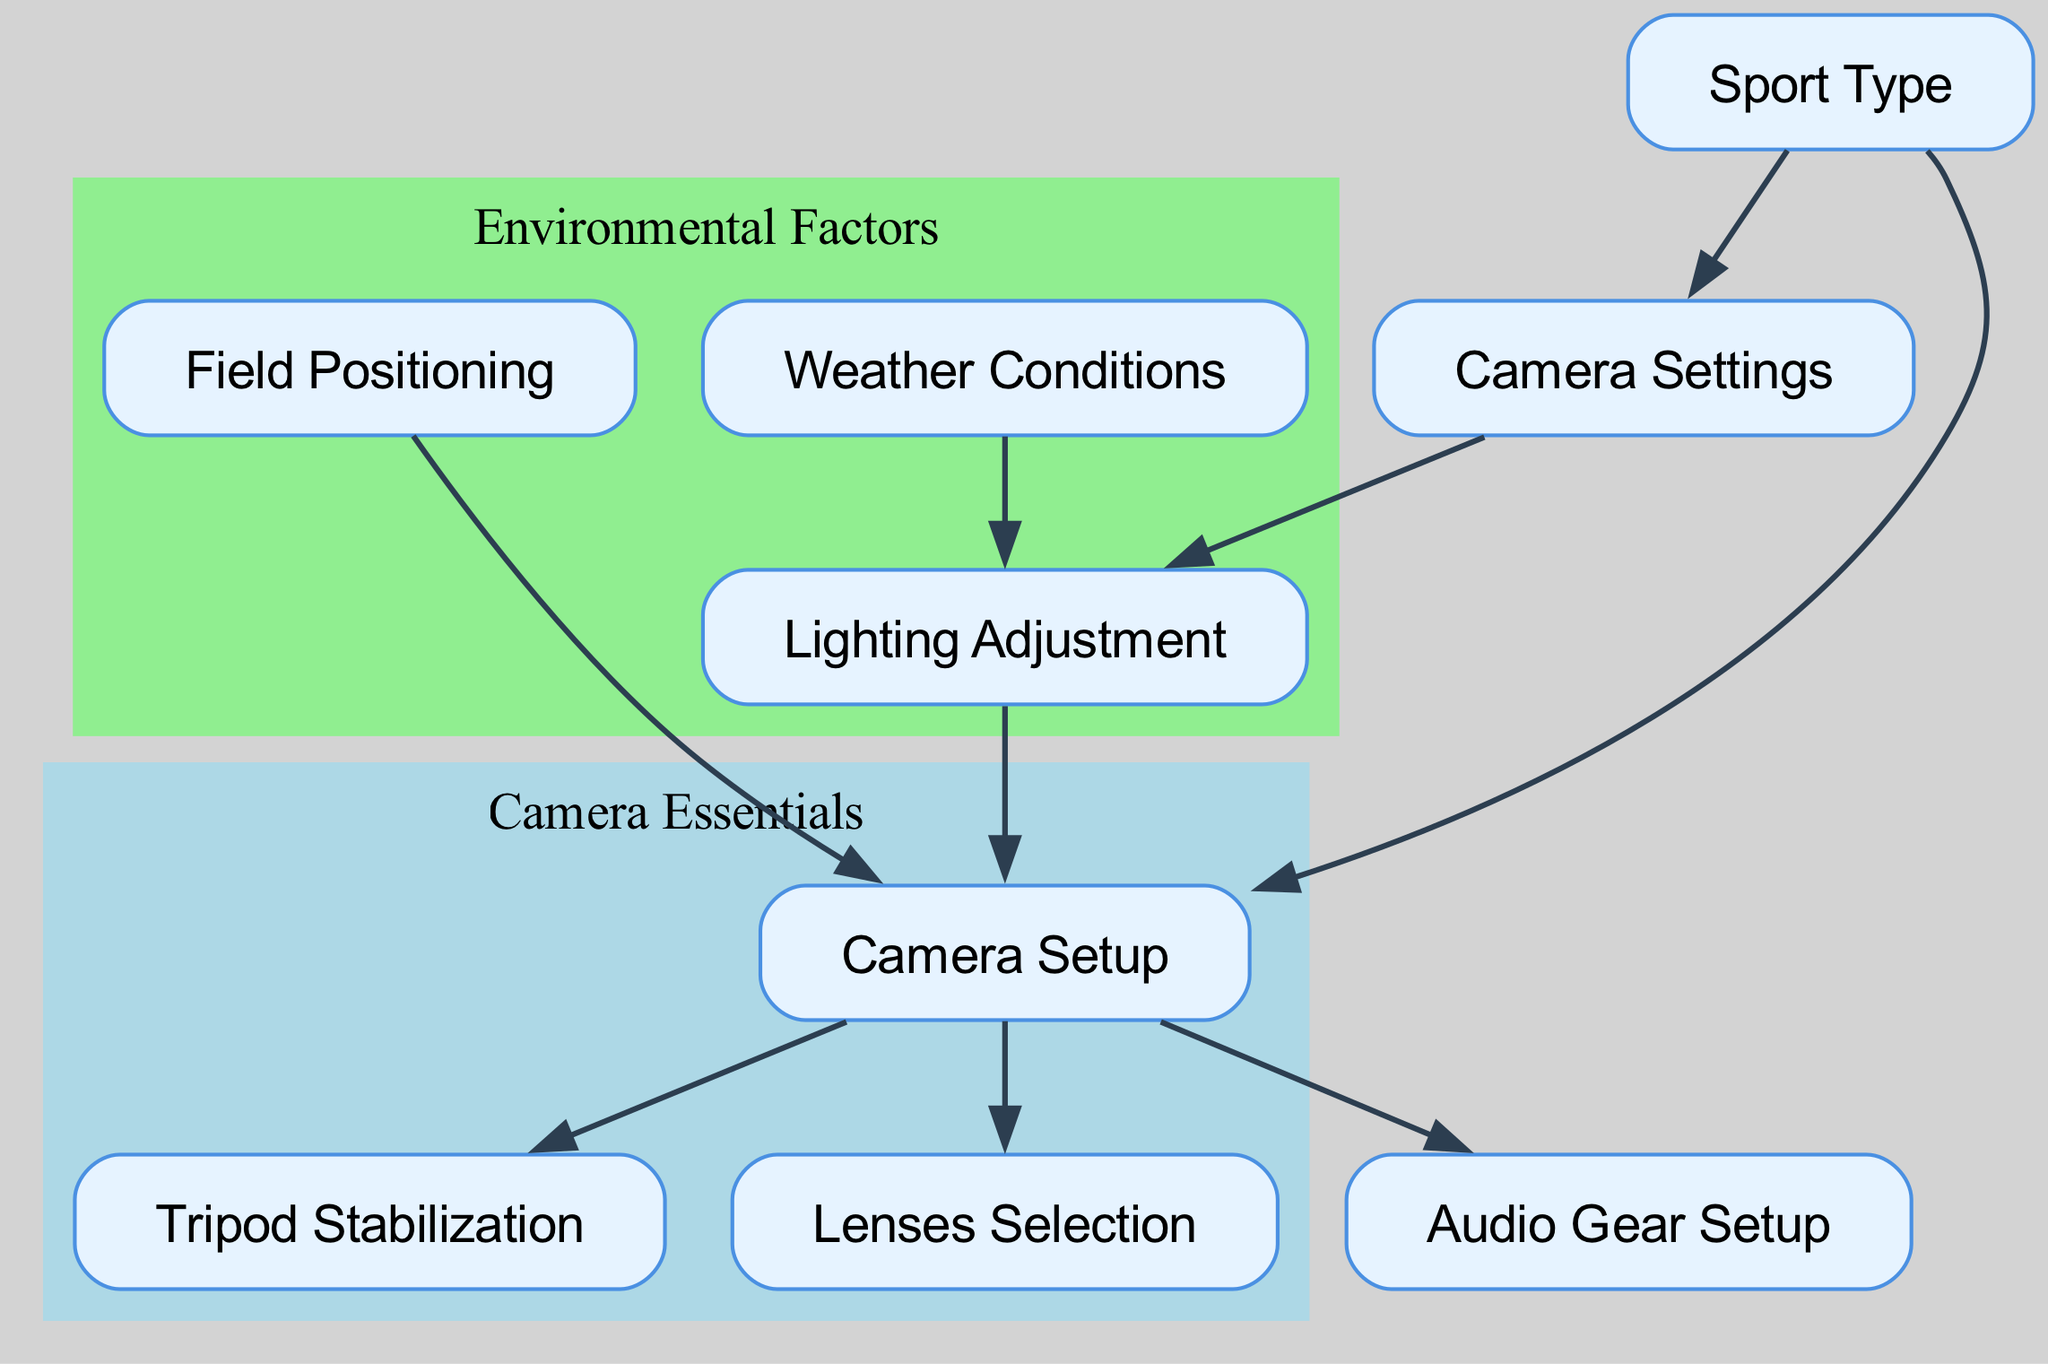What are the three main nodes under 'Camera Essentials'? The diagram shows three main nodes grouped under 'Camera Essentials': Camera Setup, Lenses Selection, and Tripod Stabilization.
Answer: Camera Setup, Lenses Selection, Tripod Stabilization Which node indicates the environmental factors affecting equipment setup? The diagram has a subgraph labeled 'Environmental Factors' which includes Weather Conditions, Lighting Adjustment, and Field Positioning.
Answer: Weather Conditions How many edges are present in the diagram? By counting the directed edges connecting nodes, we find that there are 9 edges in total.
Answer: 9 What does 'Sport Type' connect to in the diagram? The directed graph shows that 'Sport Type' connects to 'Camera Setup' and 'Camera Settings'.
Answer: Camera Setup, Camera Settings What is the significance of 'Weather Conditions' in relation to 'Lighting Adjustment'? The diagram indicates a direct connection from 'Weather Conditions' to 'Lighting Adjustment', signifying that the weather influences the adjustment of lighting during filming.
Answer: Influences Which node comes after 'Field Positioning' in the setup process? Following the directed edge from 'Field Positioning', the next node depicting the setup process is 'Camera Setup'.
Answer: Camera Setup What condition must be adjusted based on 'Camera Settings'? The diagram connects 'Camera Settings' to 'Lighting Adjustment', indicating that lighting needs to be adjusted according to the camera settings.
Answer: Lighting Adjustment Which node is a prerequisite to 'Audio Gear Setup'? The directed graph shows that 'Audio Gear Setup' is dependent on 'Camera Setup', as there is an edge from 'Camera Setup' to 'Audio Gear Setup'.
Answer: Camera Setup How does 'Lighting Adjustment' relate to 'Weather Conditions'? The directed edge from 'Weather Conditions' to 'Lighting Adjustment' signifies that weather conditions must be considered before making lighting adjustments.
Answer: Considered 